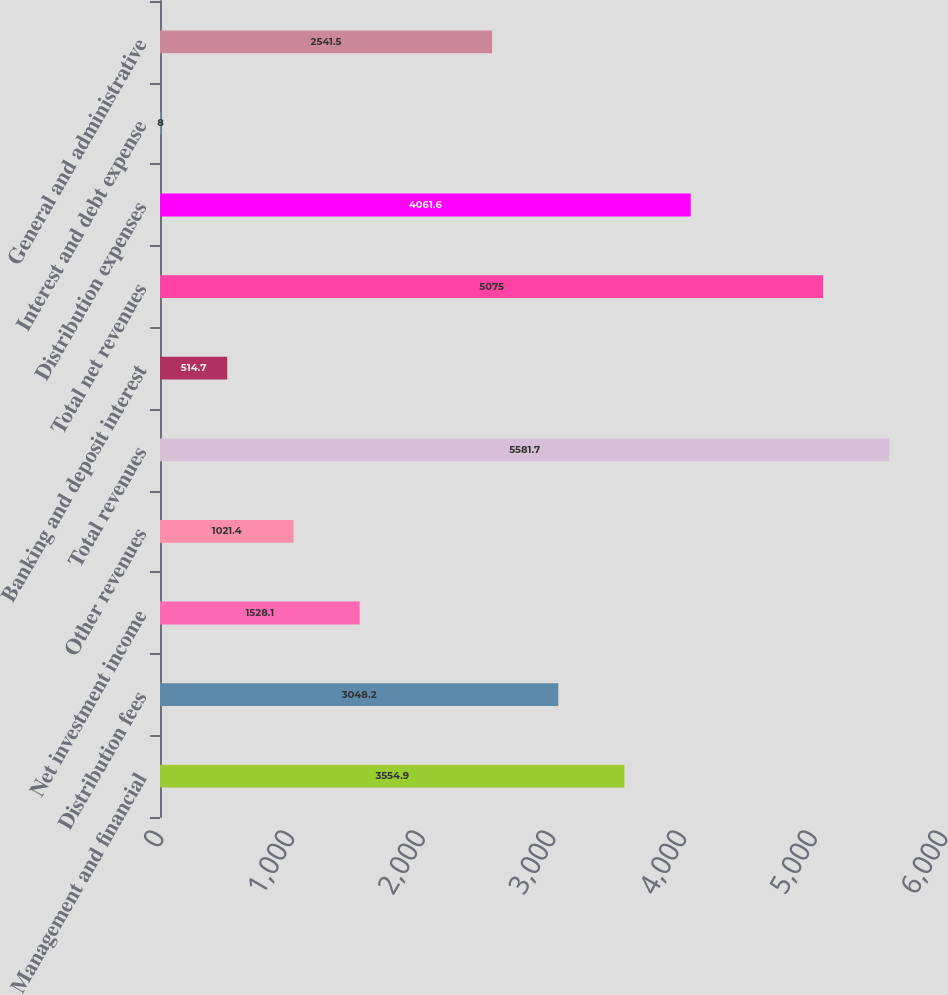Convert chart to OTSL. <chart><loc_0><loc_0><loc_500><loc_500><bar_chart><fcel>Management and financial<fcel>Distribution fees<fcel>Net investment income<fcel>Other revenues<fcel>Total revenues<fcel>Banking and deposit interest<fcel>Total net revenues<fcel>Distribution expenses<fcel>Interest and debt expense<fcel>General and administrative<nl><fcel>3554.9<fcel>3048.2<fcel>1528.1<fcel>1021.4<fcel>5581.7<fcel>514.7<fcel>5075<fcel>4061.6<fcel>8<fcel>2541.5<nl></chart> 